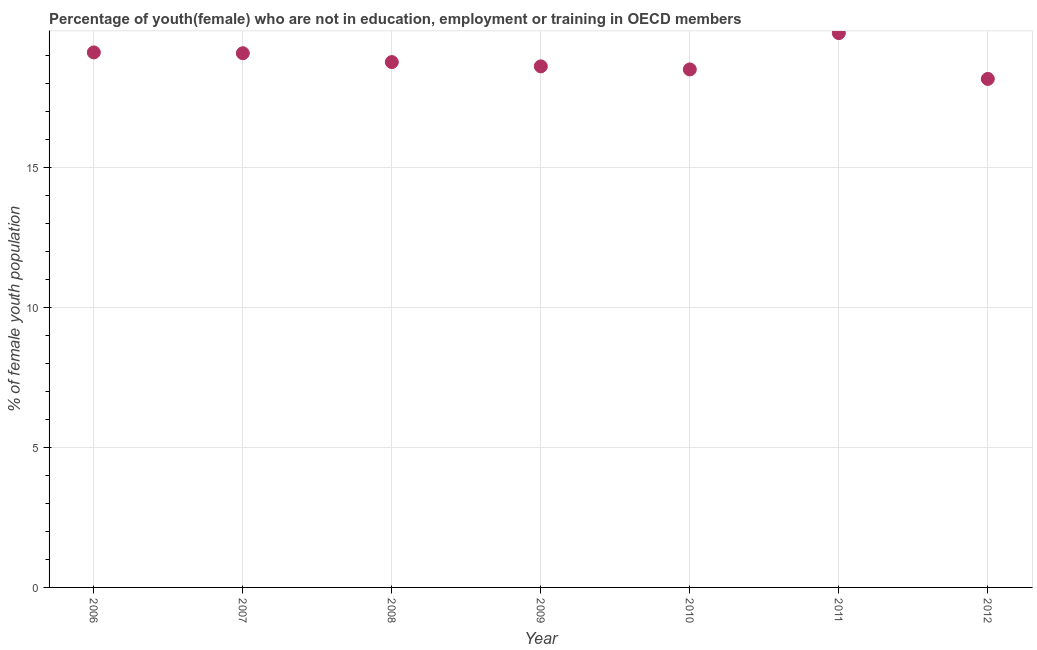What is the unemployed female youth population in 2009?
Provide a succinct answer. 18.61. Across all years, what is the maximum unemployed female youth population?
Provide a succinct answer. 19.8. Across all years, what is the minimum unemployed female youth population?
Keep it short and to the point. 18.16. In which year was the unemployed female youth population maximum?
Your response must be concise. 2011. What is the sum of the unemployed female youth population?
Make the answer very short. 132.01. What is the difference between the unemployed female youth population in 2006 and 2011?
Give a very brief answer. -0.69. What is the average unemployed female youth population per year?
Your response must be concise. 18.86. What is the median unemployed female youth population?
Offer a very short reply. 18.76. Do a majority of the years between 2012 and 2006 (inclusive) have unemployed female youth population greater than 13 %?
Provide a short and direct response. Yes. What is the ratio of the unemployed female youth population in 2010 to that in 2011?
Give a very brief answer. 0.93. Is the unemployed female youth population in 2006 less than that in 2012?
Keep it short and to the point. No. What is the difference between the highest and the second highest unemployed female youth population?
Offer a very short reply. 0.69. What is the difference between the highest and the lowest unemployed female youth population?
Your response must be concise. 1.64. In how many years, is the unemployed female youth population greater than the average unemployed female youth population taken over all years?
Ensure brevity in your answer.  3. How many years are there in the graph?
Provide a short and direct response. 7. Does the graph contain grids?
Make the answer very short. Yes. What is the title of the graph?
Offer a terse response. Percentage of youth(female) who are not in education, employment or training in OECD members. What is the label or title of the X-axis?
Offer a terse response. Year. What is the label or title of the Y-axis?
Keep it short and to the point. % of female youth population. What is the % of female youth population in 2006?
Make the answer very short. 19.11. What is the % of female youth population in 2007?
Your response must be concise. 19.08. What is the % of female youth population in 2008?
Ensure brevity in your answer.  18.76. What is the % of female youth population in 2009?
Your response must be concise. 18.61. What is the % of female youth population in 2010?
Provide a short and direct response. 18.5. What is the % of female youth population in 2011?
Offer a terse response. 19.8. What is the % of female youth population in 2012?
Your response must be concise. 18.16. What is the difference between the % of female youth population in 2006 and 2007?
Keep it short and to the point. 0.03. What is the difference between the % of female youth population in 2006 and 2008?
Offer a very short reply. 0.35. What is the difference between the % of female youth population in 2006 and 2009?
Your answer should be compact. 0.5. What is the difference between the % of female youth population in 2006 and 2010?
Provide a succinct answer. 0.61. What is the difference between the % of female youth population in 2006 and 2011?
Provide a succinct answer. -0.69. What is the difference between the % of female youth population in 2006 and 2012?
Ensure brevity in your answer.  0.95. What is the difference between the % of female youth population in 2007 and 2008?
Provide a succinct answer. 0.32. What is the difference between the % of female youth population in 2007 and 2009?
Your answer should be compact. 0.47. What is the difference between the % of female youth population in 2007 and 2010?
Offer a very short reply. 0.58. What is the difference between the % of female youth population in 2007 and 2011?
Ensure brevity in your answer.  -0.72. What is the difference between the % of female youth population in 2007 and 2012?
Keep it short and to the point. 0.92. What is the difference between the % of female youth population in 2008 and 2009?
Your answer should be very brief. 0.15. What is the difference between the % of female youth population in 2008 and 2010?
Give a very brief answer. 0.26. What is the difference between the % of female youth population in 2008 and 2011?
Offer a terse response. -1.03. What is the difference between the % of female youth population in 2008 and 2012?
Ensure brevity in your answer.  0.6. What is the difference between the % of female youth population in 2009 and 2010?
Keep it short and to the point. 0.11. What is the difference between the % of female youth population in 2009 and 2011?
Provide a succinct answer. -1.19. What is the difference between the % of female youth population in 2009 and 2012?
Provide a succinct answer. 0.45. What is the difference between the % of female youth population in 2010 and 2011?
Offer a terse response. -1.3. What is the difference between the % of female youth population in 2010 and 2012?
Provide a succinct answer. 0.34. What is the difference between the % of female youth population in 2011 and 2012?
Offer a terse response. 1.64. What is the ratio of the % of female youth population in 2006 to that in 2007?
Give a very brief answer. 1. What is the ratio of the % of female youth population in 2006 to that in 2008?
Ensure brevity in your answer.  1.02. What is the ratio of the % of female youth population in 2006 to that in 2010?
Provide a succinct answer. 1.03. What is the ratio of the % of female youth population in 2006 to that in 2011?
Offer a very short reply. 0.96. What is the ratio of the % of female youth population in 2006 to that in 2012?
Provide a short and direct response. 1.05. What is the ratio of the % of female youth population in 2007 to that in 2010?
Your response must be concise. 1.03. What is the ratio of the % of female youth population in 2007 to that in 2011?
Offer a very short reply. 0.96. What is the ratio of the % of female youth population in 2007 to that in 2012?
Offer a terse response. 1.05. What is the ratio of the % of female youth population in 2008 to that in 2009?
Your answer should be compact. 1.01. What is the ratio of the % of female youth population in 2008 to that in 2010?
Keep it short and to the point. 1.01. What is the ratio of the % of female youth population in 2008 to that in 2011?
Provide a succinct answer. 0.95. What is the ratio of the % of female youth population in 2008 to that in 2012?
Your answer should be compact. 1.03. What is the ratio of the % of female youth population in 2009 to that in 2011?
Give a very brief answer. 0.94. What is the ratio of the % of female youth population in 2009 to that in 2012?
Keep it short and to the point. 1.02. What is the ratio of the % of female youth population in 2010 to that in 2011?
Your response must be concise. 0.94. What is the ratio of the % of female youth population in 2011 to that in 2012?
Keep it short and to the point. 1.09. 